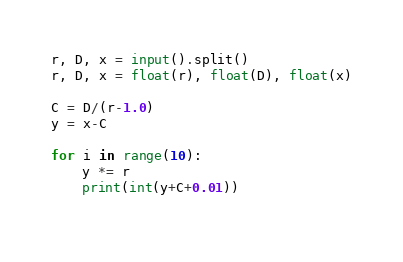<code> <loc_0><loc_0><loc_500><loc_500><_Python_>r, D, x = input().split()
r, D, x = float(r), float(D), float(x)

C = D/(r-1.0)
y = x-C

for i in range(10):
    y *= r
    print(int(y+C+0.01))
    
</code> 